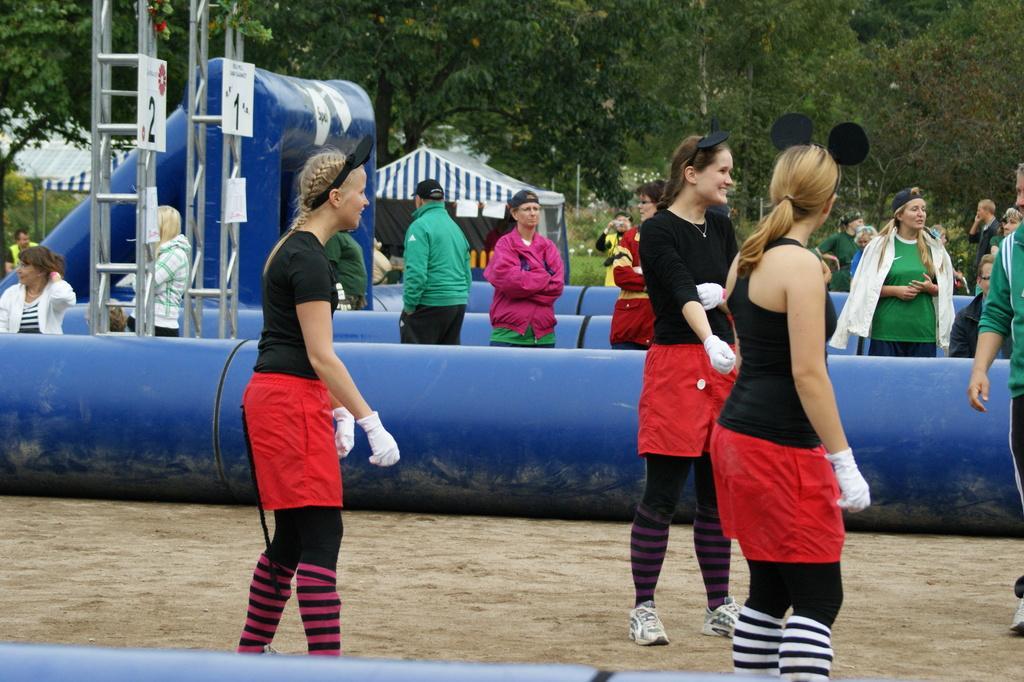Please provide a concise description of this image. In this image there are people standing on ground and there are balloons, in the background there are trees. 